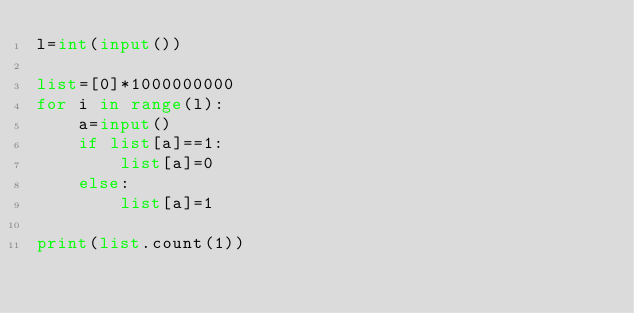<code> <loc_0><loc_0><loc_500><loc_500><_Python_>l=int(input())

list=[0]*1000000000
for i in range(l):
    a=input()
    if list[a]==1:
        list[a]=0
    else:
        list[a]=1

print(list.count(1))</code> 